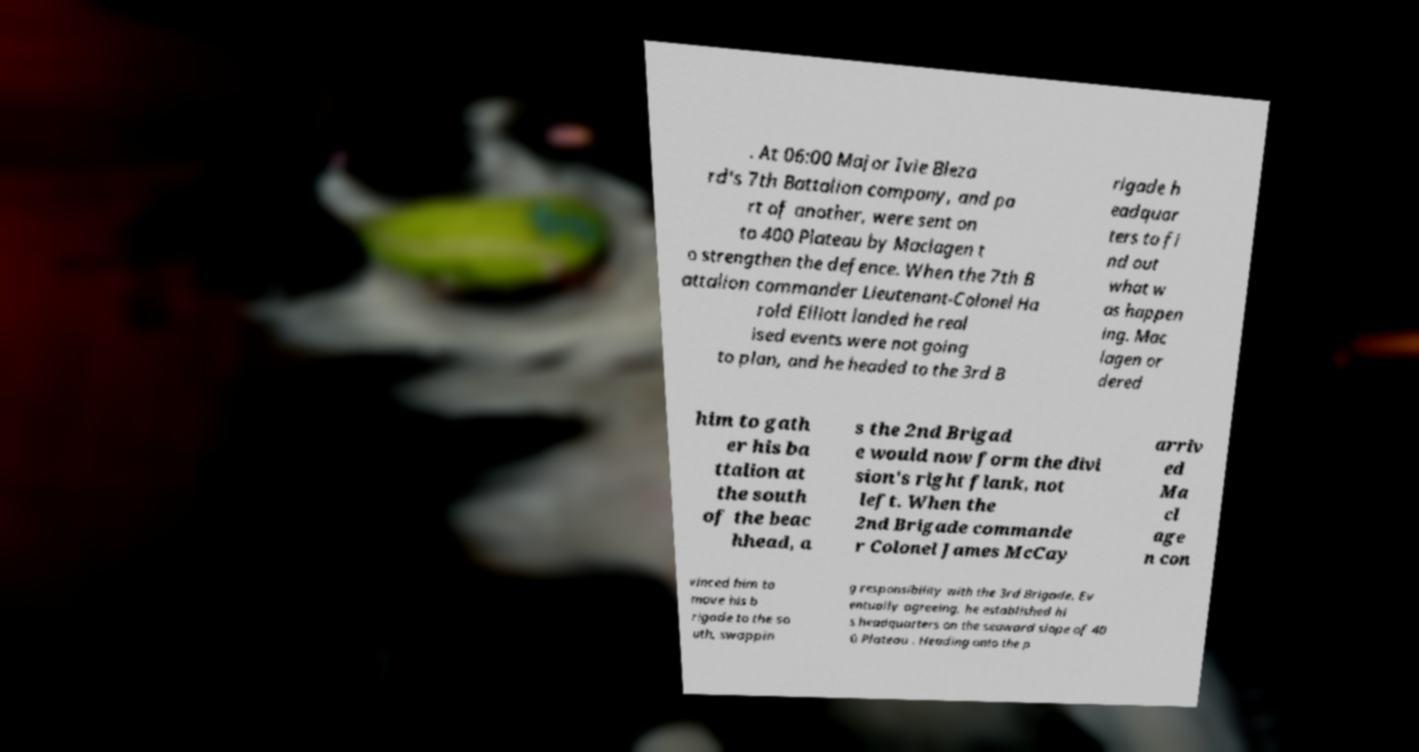Please identify and transcribe the text found in this image. . At 06:00 Major Ivie Bleza rd's 7th Battalion company, and pa rt of another, were sent on to 400 Plateau by Maclagen t o strengthen the defence. When the 7th B attalion commander Lieutenant-Colonel Ha rold Elliott landed he real ised events were not going to plan, and he headed to the 3rd B rigade h eadquar ters to fi nd out what w as happen ing. Mac lagen or dered him to gath er his ba ttalion at the south of the beac hhead, a s the 2nd Brigad e would now form the divi sion's right flank, not left. When the 2nd Brigade commande r Colonel James McCay arriv ed Ma cl age n con vinced him to move his b rigade to the so uth, swappin g responsibility with the 3rd Brigade. Ev entually agreeing, he established hi s headquarters on the seaward slope of 40 0 Plateau . Heading onto the p 